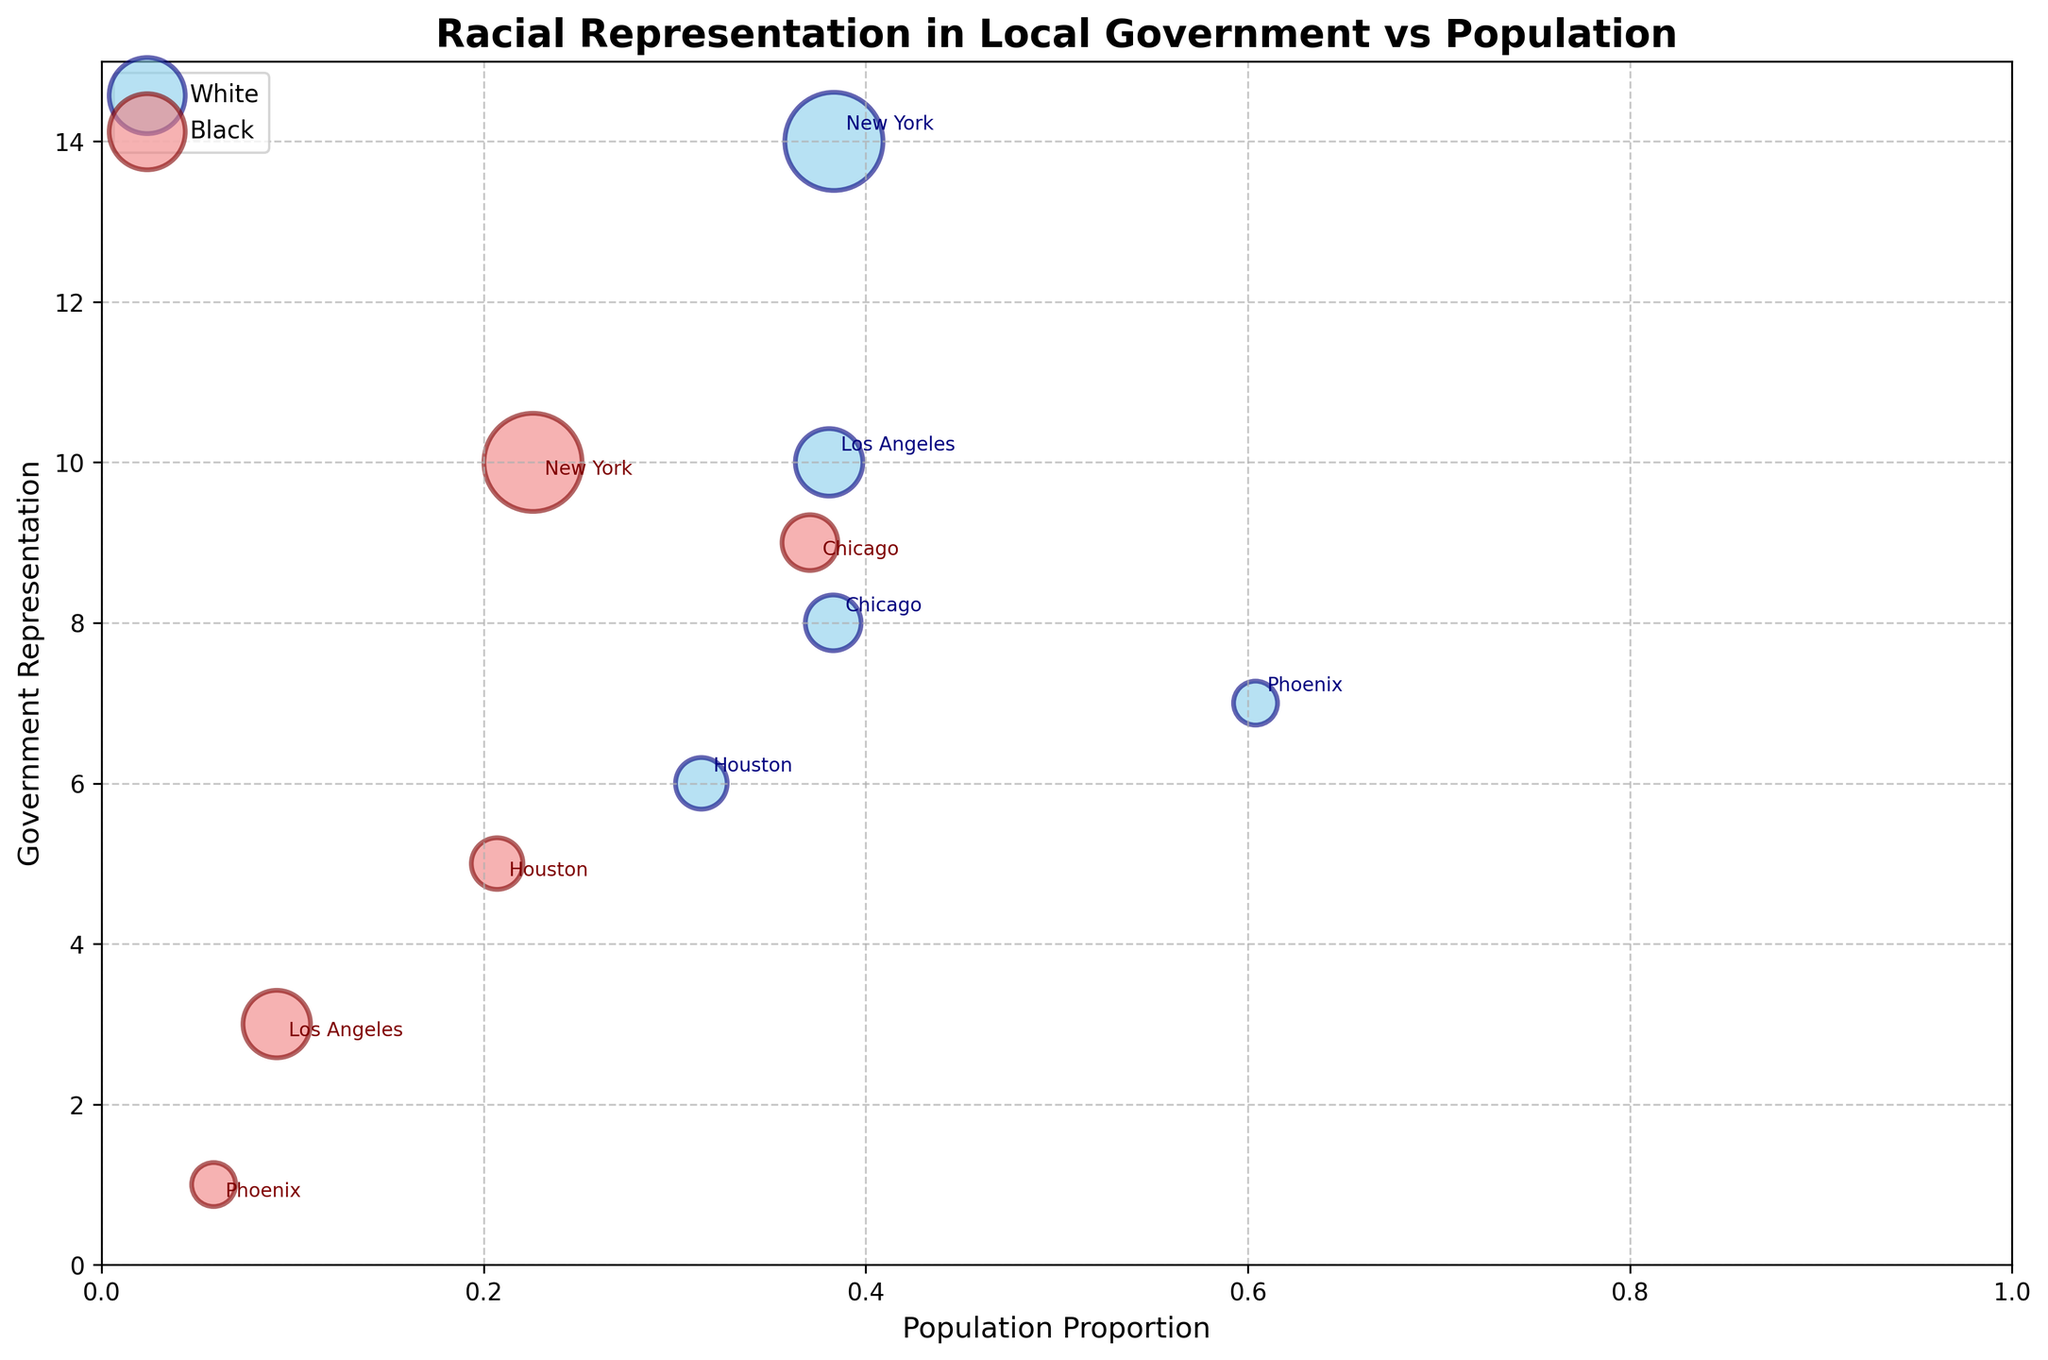What's the title of the figure? The title of the figure is indicated at the top in bold text, summarizing the main theme or topic being visualized.
Answer: Racial Representation in Local Government vs Population What are the x-axis and y-axis labels? The x-axis and y-axis labels are provided to give context to what each axis represents. The x-axis is labeled 'Population Proportion' and the y-axis is labeled 'Government Representation'.
Answer: Population Proportion, Government Representation Which city has the largest bubble size? By observing the plot, the size of each bubble indicates the population of the city. The largest bubble corresponds to the city with the highest population.
Answer: New York How many racial groups are represented on the bubble chart? The bubble chart uses color and labeling to indicate different racial groups being represented. Specifically, the colors and legend indicate the racial groups shown.
Answer: Two What are the colors representing different racial groups? The colors on the bubbles are used to visually distinguish between different racial groups. From the legend, we can see 'skyblue' represents White and 'lightcoral' represents Black.
Answer: White and Black Which city has a higher representation of Black people relative to their population, New York or Chicago? By comparing the positions of the bubbles for New York and Chicago along the x-axis (population proportion of Black people) and y-axis (Black representation), we can determine which city has higher relative representation.
Answer: Chicago What city has the lowest White representation despite having a significant White population? This involves looking at the bubble placement on the y-axis for 'White Representation' and comparing those cities which have a considerable proportion of white population on the x-axis but lower placement on the y-axis.
Answer: Houston Compare the White and Black representation in Phoenix. Which racial group is better represented in local government relative to their population? Find the two points for Phoenix: one for White and one for Black. Compare the y-values relative to their x-values to determine which racial group is better represented.
Answer: White Which city has an equal representation for both White and Black populations? The figure needs to be observed to find a city where the bubbles for White and Black populations align vertically, indicating equal representation in local government for both groups.
Answer: None What is the approximate population of the city represented by the smallest bubbles on the figure? The smallest bubbles indicate the city with the lowest population. Examine and compare the more expansive plot for bubble sizes, referencing city labels.
Answer: Phoenix 